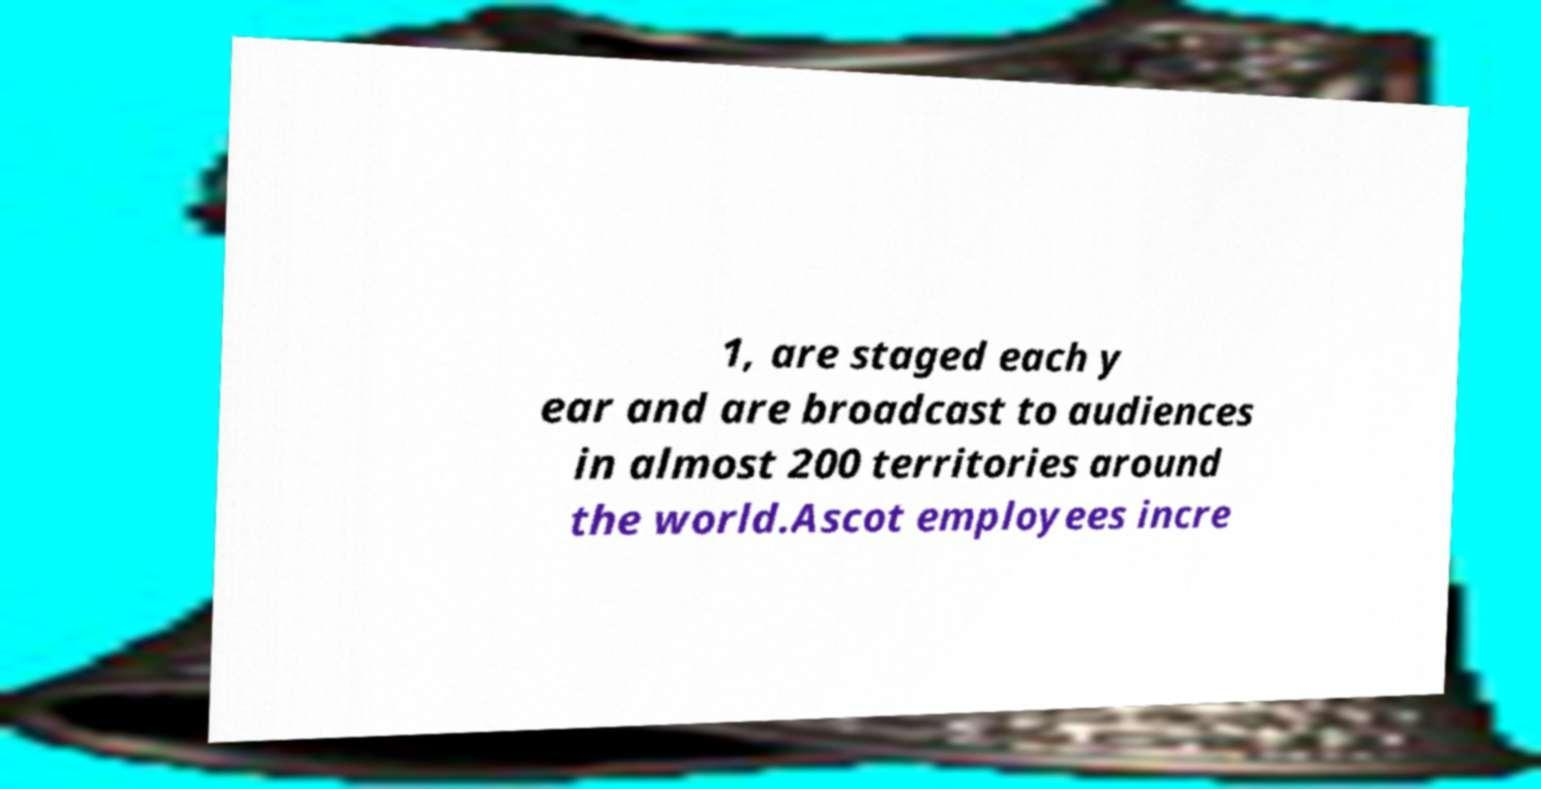Can you accurately transcribe the text from the provided image for me? 1, are staged each y ear and are broadcast to audiences in almost 200 territories around the world.Ascot employees incre 